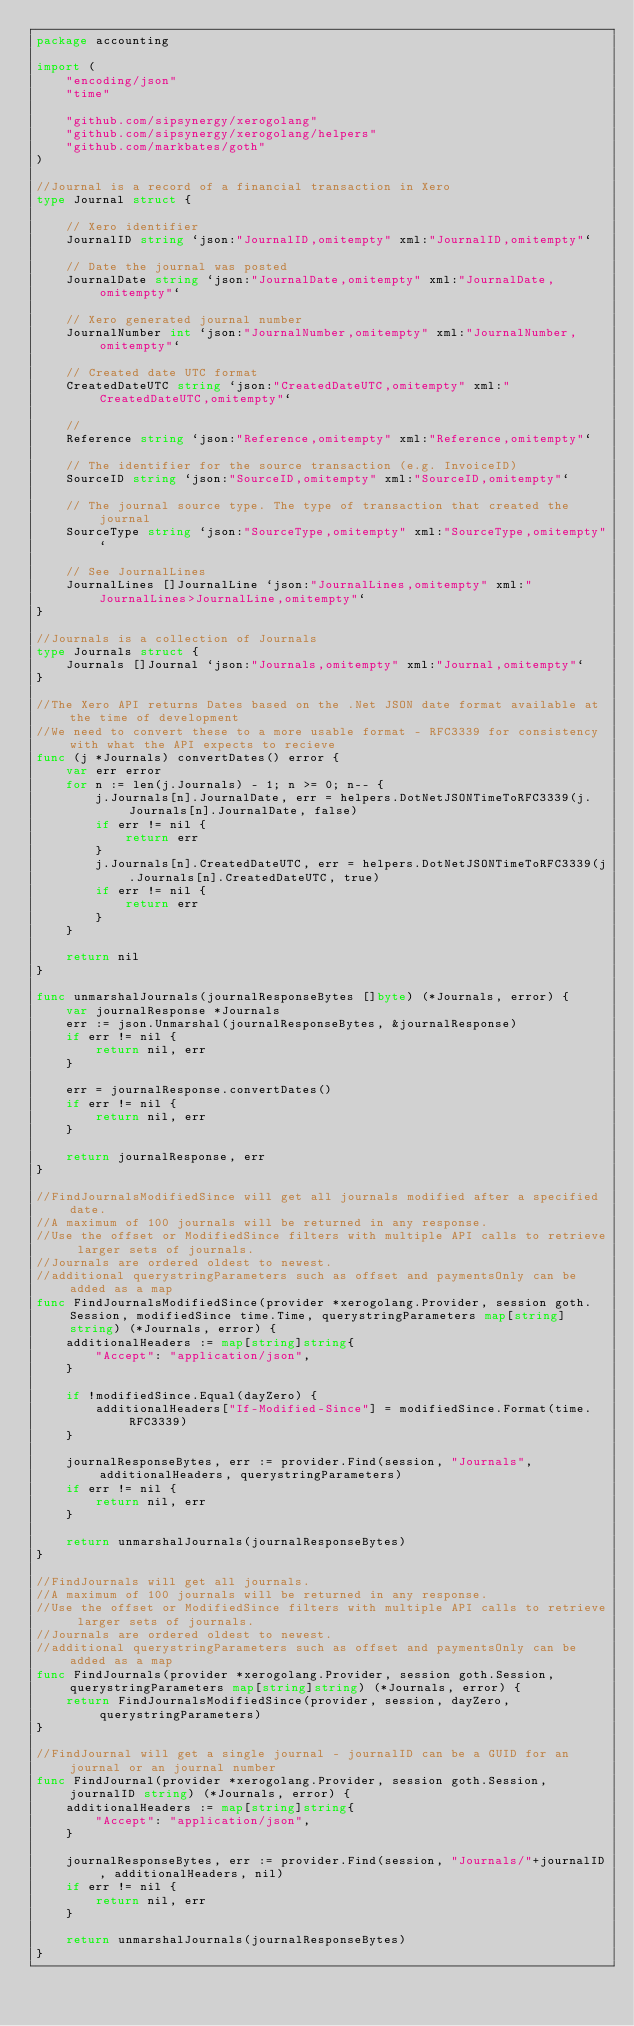<code> <loc_0><loc_0><loc_500><loc_500><_Go_>package accounting

import (
	"encoding/json"
	"time"

	"github.com/sipsynergy/xerogolang"
	"github.com/sipsynergy/xerogolang/helpers"
	"github.com/markbates/goth"
)

//Journal is a record of a financial transaction in Xero
type Journal struct {

	// Xero identifier
	JournalID string `json:"JournalID,omitempty" xml:"JournalID,omitempty"`

	// Date the journal was posted
	JournalDate string `json:"JournalDate,omitempty" xml:"JournalDate,omitempty"`

	// Xero generated journal number
	JournalNumber int `json:"JournalNumber,omitempty" xml:"JournalNumber,omitempty"`

	// Created date UTC format
	CreatedDateUTC string `json:"CreatedDateUTC,omitempty" xml:"CreatedDateUTC,omitempty"`

	//
	Reference string `json:"Reference,omitempty" xml:"Reference,omitempty"`

	// The identifier for the source transaction (e.g. InvoiceID)
	SourceID string `json:"SourceID,omitempty" xml:"SourceID,omitempty"`

	// The journal source type. The type of transaction that created the journal
	SourceType string `json:"SourceType,omitempty" xml:"SourceType,omitempty"`

	// See JournalLines
	JournalLines []JournalLine `json:"JournalLines,omitempty" xml:"JournalLines>JournalLine,omitempty"`
}

//Journals is a collection of Journals
type Journals struct {
	Journals []Journal `json:"Journals,omitempty" xml:"Journal,omitempty"`
}

//The Xero API returns Dates based on the .Net JSON date format available at the time of development
//We need to convert these to a more usable format - RFC3339 for consistency with what the API expects to recieve
func (j *Journals) convertDates() error {
	var err error
	for n := len(j.Journals) - 1; n >= 0; n-- {
		j.Journals[n].JournalDate, err = helpers.DotNetJSONTimeToRFC3339(j.Journals[n].JournalDate, false)
		if err != nil {
			return err
		}
		j.Journals[n].CreatedDateUTC, err = helpers.DotNetJSONTimeToRFC3339(j.Journals[n].CreatedDateUTC, true)
		if err != nil {
			return err
		}
	}

	return nil
}

func unmarshalJournals(journalResponseBytes []byte) (*Journals, error) {
	var journalResponse *Journals
	err := json.Unmarshal(journalResponseBytes, &journalResponse)
	if err != nil {
		return nil, err
	}

	err = journalResponse.convertDates()
	if err != nil {
		return nil, err
	}

	return journalResponse, err
}

//FindJournalsModifiedSince will get all journals modified after a specified date.
//A maximum of 100 journals will be returned in any response.
//Use the offset or ModifiedSince filters with multiple API calls to retrieve larger sets of journals.
//Journals are ordered oldest to newest.
//additional querystringParameters such as offset and paymentsOnly can be added as a map
func FindJournalsModifiedSince(provider *xerogolang.Provider, session goth.Session, modifiedSince time.Time, querystringParameters map[string]string) (*Journals, error) {
	additionalHeaders := map[string]string{
		"Accept": "application/json",
	}

	if !modifiedSince.Equal(dayZero) {
		additionalHeaders["If-Modified-Since"] = modifiedSince.Format(time.RFC3339)
	}

	journalResponseBytes, err := provider.Find(session, "Journals", additionalHeaders, querystringParameters)
	if err != nil {
		return nil, err
	}

	return unmarshalJournals(journalResponseBytes)
}

//FindJournals will get all journals.
//A maximum of 100 journals will be returned in any response.
//Use the offset or ModifiedSince filters with multiple API calls to retrieve larger sets of journals.
//Journals are ordered oldest to newest.
//additional querystringParameters such as offset and paymentsOnly can be added as a map
func FindJournals(provider *xerogolang.Provider, session goth.Session, querystringParameters map[string]string) (*Journals, error) {
	return FindJournalsModifiedSince(provider, session, dayZero, querystringParameters)
}

//FindJournal will get a single journal - journalID can be a GUID for an journal or an journal number
func FindJournal(provider *xerogolang.Provider, session goth.Session, journalID string) (*Journals, error) {
	additionalHeaders := map[string]string{
		"Accept": "application/json",
	}

	journalResponseBytes, err := provider.Find(session, "Journals/"+journalID, additionalHeaders, nil)
	if err != nil {
		return nil, err
	}

	return unmarshalJournals(journalResponseBytes)
}
</code> 